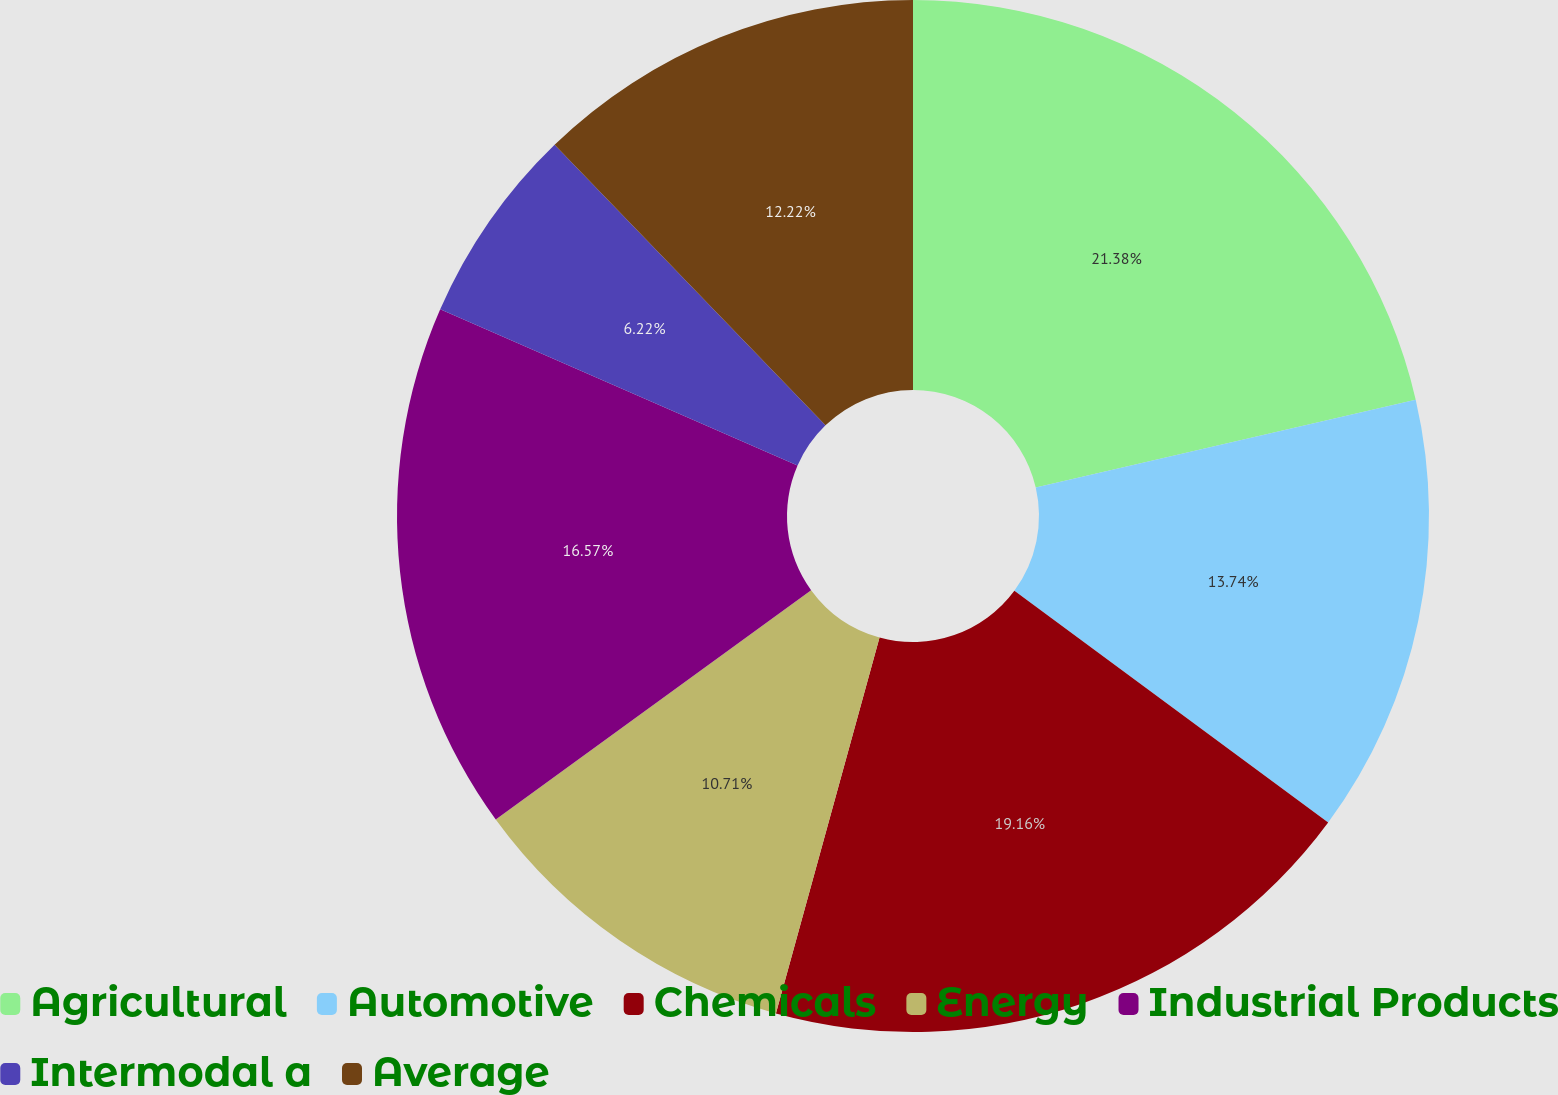Convert chart to OTSL. <chart><loc_0><loc_0><loc_500><loc_500><pie_chart><fcel>Agricultural<fcel>Automotive<fcel>Chemicals<fcel>Energy<fcel>Industrial Products<fcel>Intermodal a<fcel>Average<nl><fcel>21.38%<fcel>13.74%<fcel>19.16%<fcel>10.71%<fcel>16.57%<fcel>6.22%<fcel>12.22%<nl></chart> 